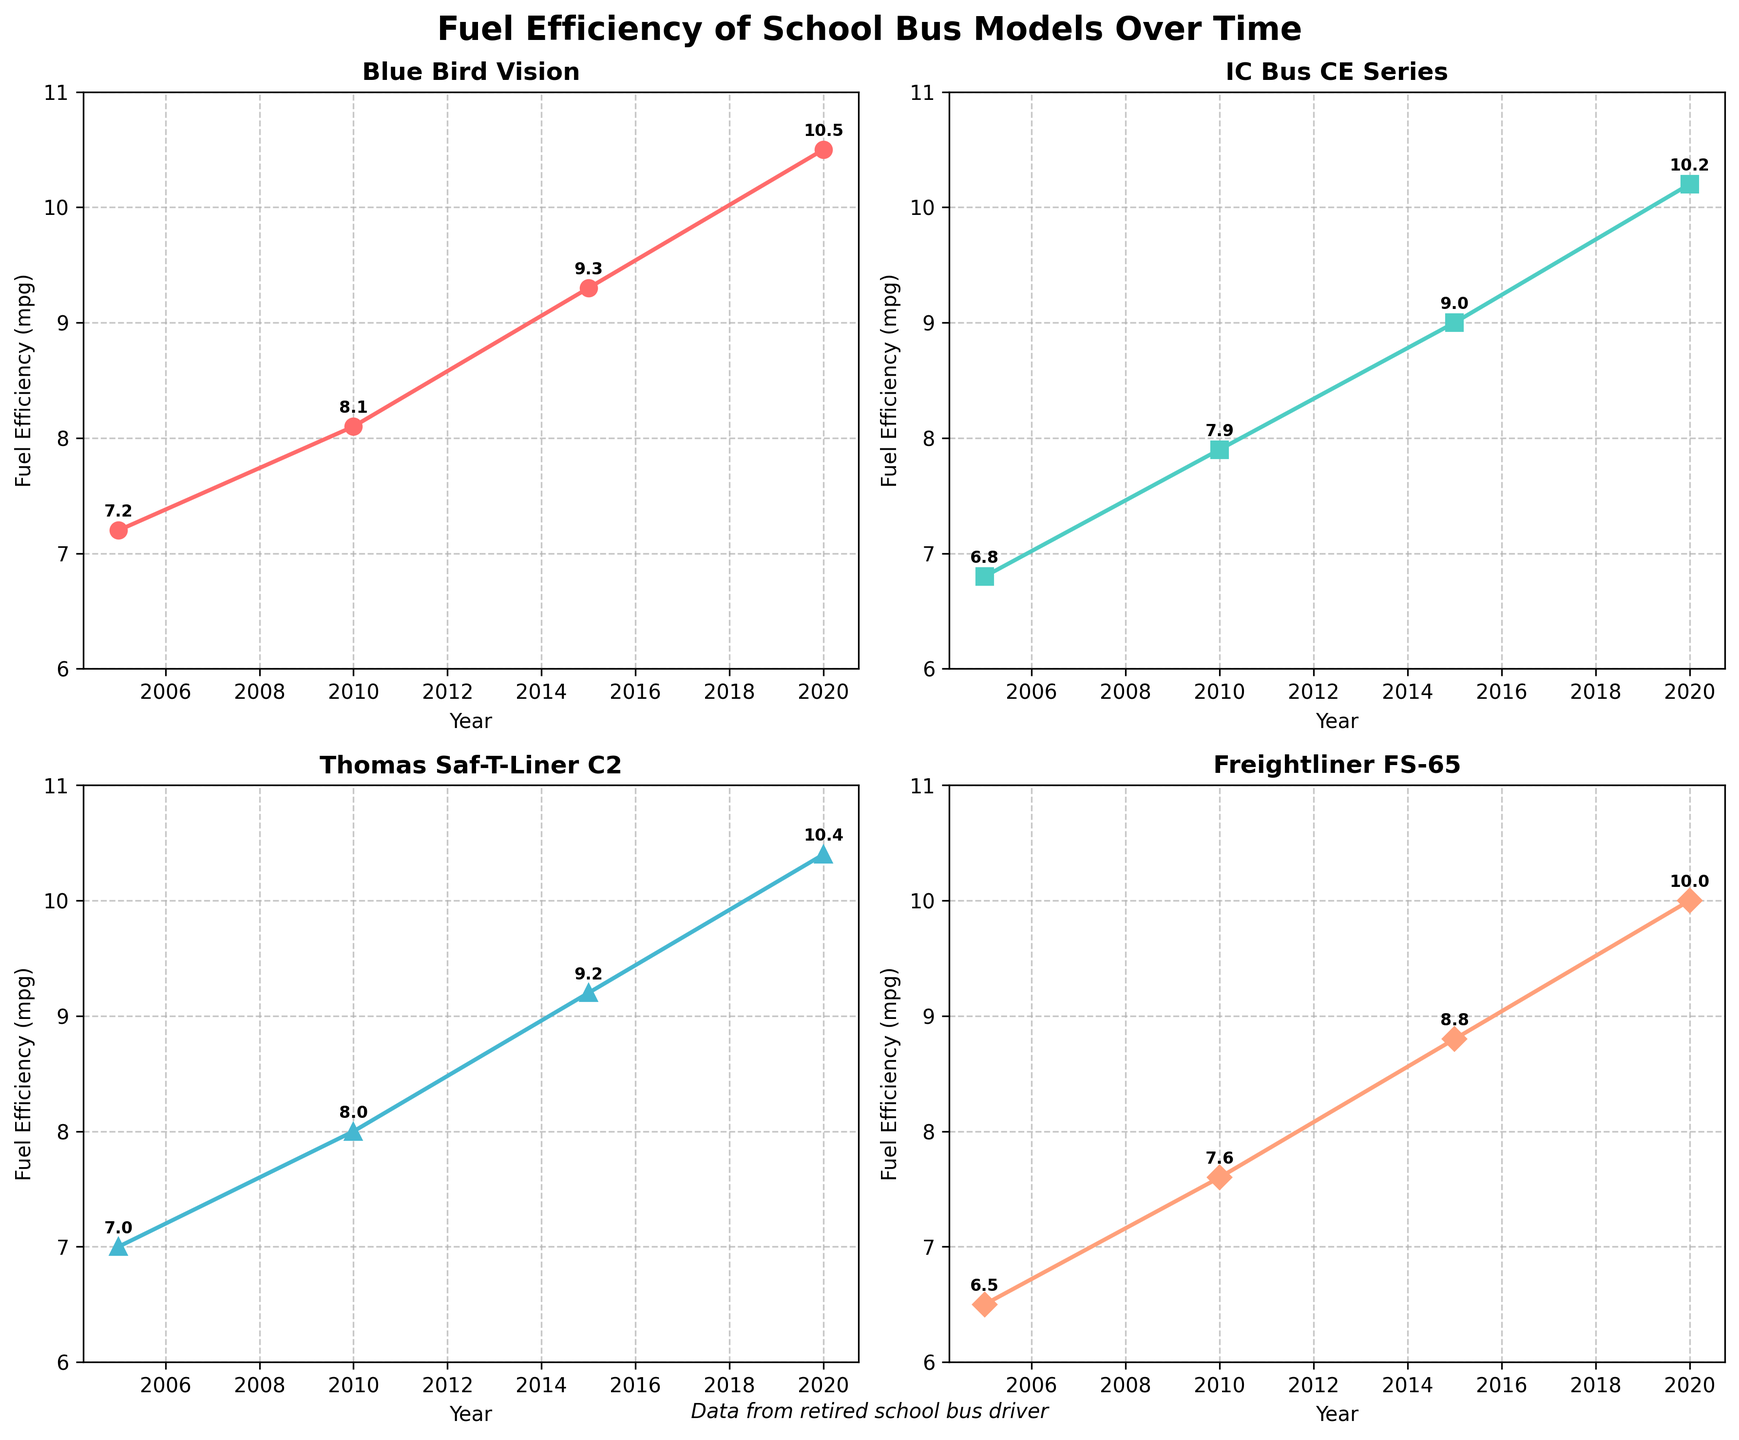What's the title of the figure? The title is located at the top center of the figure. It reads "Fuel Efficiency of School Bus Models Over Time" in bold letters.
Answer: Fuel Efficiency of School Bus Models Over Time How many school bus models are compared in the figure? There are four subplots, each with its own title indicating the school bus model. The models are Blue Bird Vision, IC Bus CE Series, Thomas Saf-T-Liner C2, and Freightliner FS-65.
Answer: 4 In which year did the Blue Bird Vision model have the highest fuel efficiency? By observing the plot for the Blue Bird Vision model, we see that the fuel efficiency increases each year, reaching its peak in 2020.
Answer: 2020 What's the average fuel efficiency of the IC Bus CE Series model over the years? To find the average, add the values for the IC Bus CE Series model (6.8, 7.9, 9.0, 10.2) and divide by the number of data points: (6.8 + 7.9 + 9.0 + 10.2) / 4 = 33.9 / 4 = 8.475.
Answer: 8.475 Which bus model had the greatest increase in fuel efficiency from 2005 to 2020? Calculate the increase for each model: Blue Bird Vision (10.5 - 7.2 = 3.3), IC Bus CE Series (10.2 - 6.8 = 3.4), Thomas Saf-T-Liner C2 (10.4 - 7.0 = 3.4), Freightliner FS-65 (10.0 - 6.5 = 3.5). The Freightliner FS-65 had the greatest increase.
Answer: Freightliner FS-65 By how much did the fuel efficiency of the Thomas Saf-T-Liner C2 model improve from 2005 to 2010? Subtract the 2005 value from the 2010 value for the Thomas Saf-T-Liner C2 model: 8.0 - 7.0 = 1.0.
Answer: 1.0 Which year shows the smallest difference in fuel efficiency between the Blue Bird Vision and IC Bus CE Series models? Calculate the differences for each year: 2005 (7.2 - 6.8 = 0.4), 2010 (8.1 - 7.9 = 0.2), 2015 (9.3 - 9.0 = 0.3), 2020 (10.5 - 10.2 = 0.3). The smallest difference is in 2010.
Answer: 2010 Rank the bus models by their fuel efficiency in the year 2015 from highest to lowest. Compare the 2015 values: Blue Bird Vision (9.3), IC Bus CE Series (9.0), Thomas Saf-T-Liner C2 (9.2), Freightliner FS-65 (8.8). The ranking is Blue Bird Vision, Thomas Saf-T-Liner C2, IC Bus CE Series, Freightliner FS-65.
Answer: Blue Bird Vision, Thomas Saf-T-Liner C2, IC Bus CE Series, Freightliner FS-65 